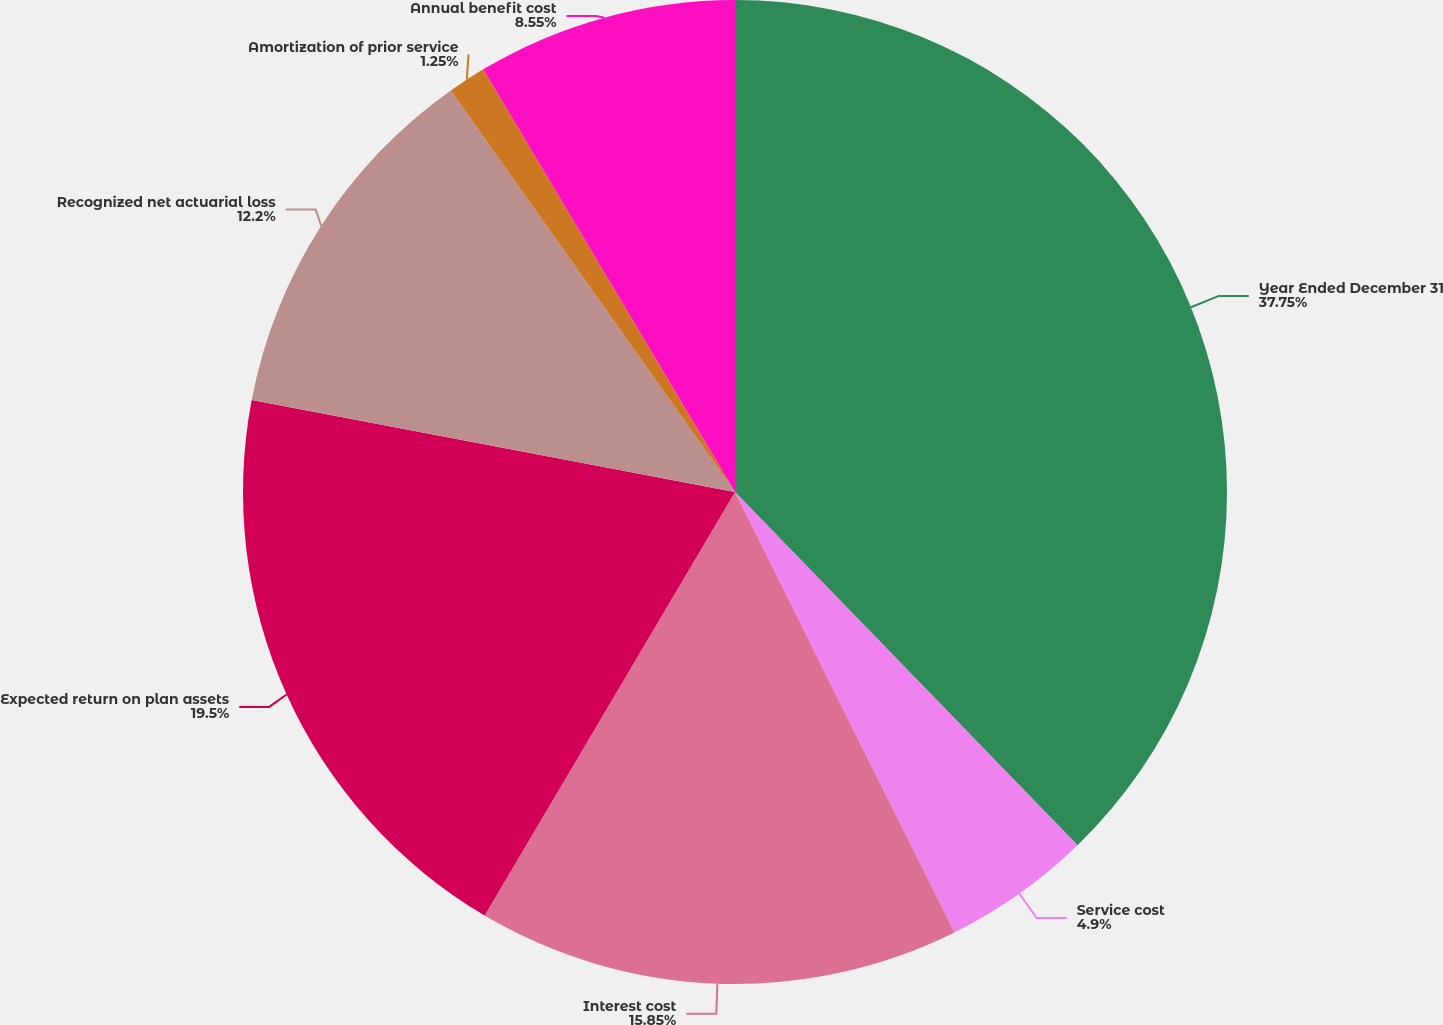<chart> <loc_0><loc_0><loc_500><loc_500><pie_chart><fcel>Year Ended December 31<fcel>Service cost<fcel>Interest cost<fcel>Expected return on plan assets<fcel>Recognized net actuarial loss<fcel>Amortization of prior service<fcel>Annual benefit cost<nl><fcel>37.74%<fcel>4.9%<fcel>15.85%<fcel>19.5%<fcel>12.2%<fcel>1.25%<fcel>8.55%<nl></chart> 